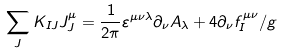<formula> <loc_0><loc_0><loc_500><loc_500>\sum _ { J } K _ { I J } J _ { J } ^ { \mu } = \frac { 1 } { 2 \pi } \varepsilon ^ { \mu \nu \lambda } \partial _ { \nu } A _ { \lambda } + 4 \partial _ { \nu } f ^ { \mu \nu } _ { I } / g</formula> 